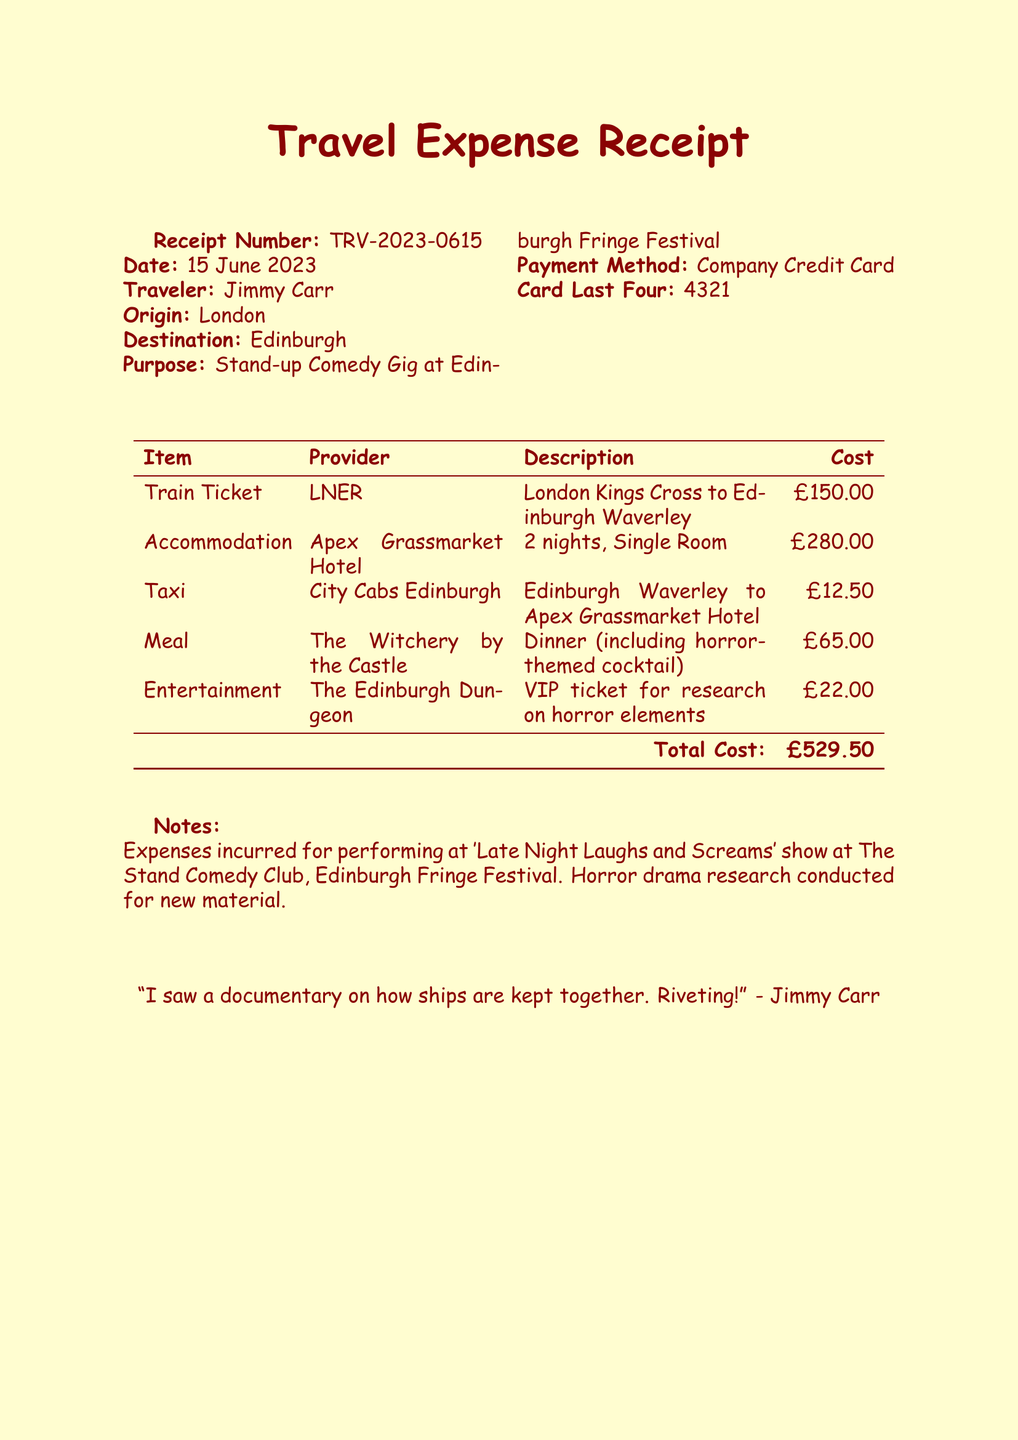What is the receipt number? The receipt number is a unique identifier for the document, which is TRV-2023-0615.
Answer: TRV-2023-0615 Who is the traveler? The traveler's name indicates who incurred the expenses, which is Jimmy Carr.
Answer: Jimmy Carr What is the total cost? The total cost is the final amount calculated from the listed expenses, which is £529.50.
Answer: £529.50 What is the purpose of the travel? The purpose outlines why the travel expenses were incurred, which is for a stand-up comedy gig.
Answer: Stand-up Comedy Gig at Edinburgh Fringe Festival What is the accommodation provider? The provider of the accommodation details who was responsible for providing lodging, which is Apex Grassmarket Hotel.
Answer: Apex Grassmarket Hotel How many nights did the traveler stay? The duration of the accommodation stay impacts the lodging costs, which is 2 nights.
Answer: 2 nights What type of ticket was purchased for travel? The type of ticket specifies the mode of transportation used, which is a return train ticket.
Answer: Train Ticket (Return) What unique experience was included in the entertainment expenses? This question requires knowledge of the specific event purchased for the entertainment category, which is a VIP ticket for research.
Answer: VIP ticket for research on horror elements What special feature was included in the meal? The meal details include a unique element, which is a horror-themed cocktail.
Answer: horror-themed cocktail 